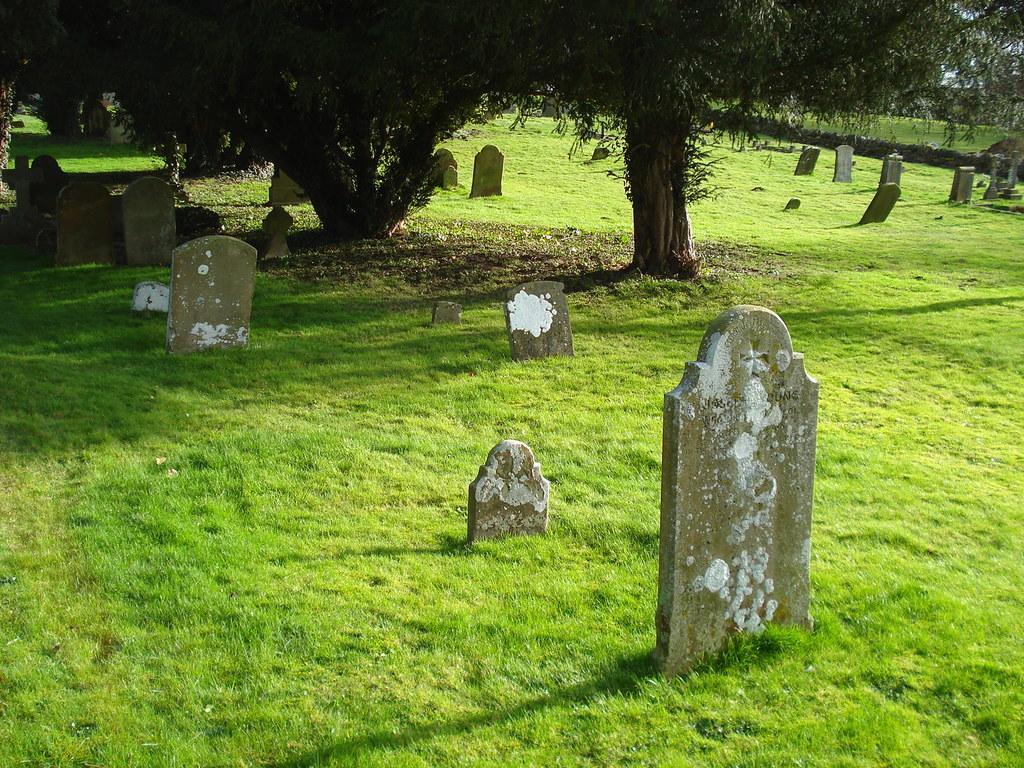How would you summarize this image in a sentence or two? In this picture, on the right side, we can see some trees, we can also see some memorial on the right side. In the background, we can see a memorial and some trees. 